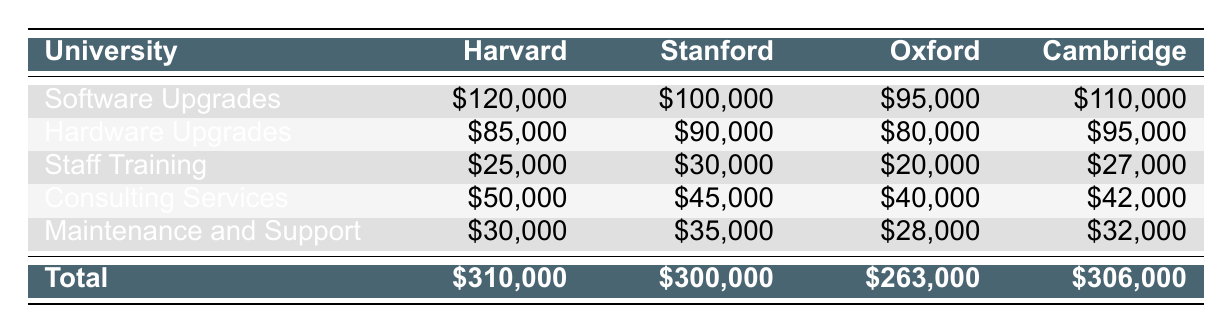What is the total cost for Harvard University Library's expenses? The total cost is shown at the bottom of the table under the total column for Harvard. It reads \$310,000.
Answer: \$310,000 Which university spent the most on hardware upgrades? By comparing the hardware expenses of each university, Stanford has \$90,000, Harvard has \$85,000, Cambridge has \$95,000, and Oxford has \$80,000. Cambridge spent the most at \$95,000.
Answer: Cambridge Is the total spending on consulting services more than \$200,000 across all universities? The total consulting expenses are: Harvard - \$50,000, Stanford - \$45,000, Oxford - \$40,000, Cambridge - \$42,000. Summing these gives \$50,000 + \$45,000 + \$40,000 + \$42,000 = \$177,000, which is less than \$200,000.
Answer: No What is the average cost of staff training across all universities? To find the average, sum the staff training costs: Harvard - \$25,000, Stanford - \$30,000, Oxford - \$20,000, Cambridge - \$27,000. Sum = \$25,000 + \$30,000 + \$20,000 + \$27,000 = \$102,000. Divide this by 4 universities, giving \$102,000 / 4 = \$25,500.
Answer: \$25,500 Did any university spend less than \$30,000 on maintenance and support? The maintenance and support costs are: Harvard - \$30,000, Stanford - \$35,000, Oxford - \$28,000, Cambridge - \$32,000. Oxford spent \$28,000, which is less than \$30,000.
Answer: Yes Which category had the highest total expenditure across all universities? To find the highest expenditure, sum the expenses within each category: Software Upgrades: \$120,000 + \$100,000 + \$95,000 + \$110,000 = \$425,000. Hardware Upgrades: \$85,000 + \$90,000 + \$80,000 + \$95,000 = \$350,000. Staff Training: \$25,000 + \$30,000 + \$20,000 + \$27,000 = \$102,000. Consulting Services: \$50,000 + \$45,000 + \$40,000 + \$42,000 = \$177,000. Maintenance and Support: \$30,000 + \$35,000 + \$28,000 + \$32,000 = \$125,000. The highest total is from Software Upgrades at \$425,000.
Answer: Software Upgrades What is the difference in cost between the highest and lowest spending on staff training? The highest is from Stanford at \$30,000 and the lowest is from Oxford at \$20,000. The difference is \$30,000 - \$20,000 = \$10,000.
Answer: \$10,000 Did all universities spend the same amount on their consulting services? The consulting expenses are different for each university: Harvard - \$50,000, Stanford - \$45,000, Oxford - \$40,000, and Cambridge - \$42,000. Since they are not all equal, the answer is no.
Answer: No 